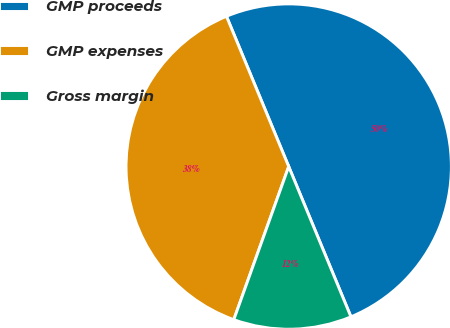Convert chart to OTSL. <chart><loc_0><loc_0><loc_500><loc_500><pie_chart><fcel>GMP proceeds<fcel>GMP expenses<fcel>Gross margin<nl><fcel>50.0%<fcel>38.27%<fcel>11.73%<nl></chart> 